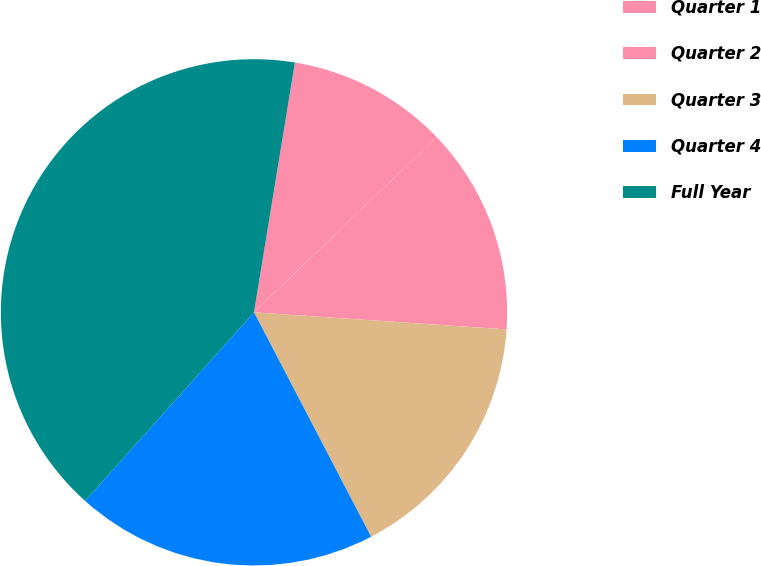Convert chart to OTSL. <chart><loc_0><loc_0><loc_500><loc_500><pie_chart><fcel>Quarter 1<fcel>Quarter 2<fcel>Quarter 3<fcel>Quarter 4<fcel>Full Year<nl><fcel>10.24%<fcel>13.25%<fcel>16.27%<fcel>19.28%<fcel>40.96%<nl></chart> 